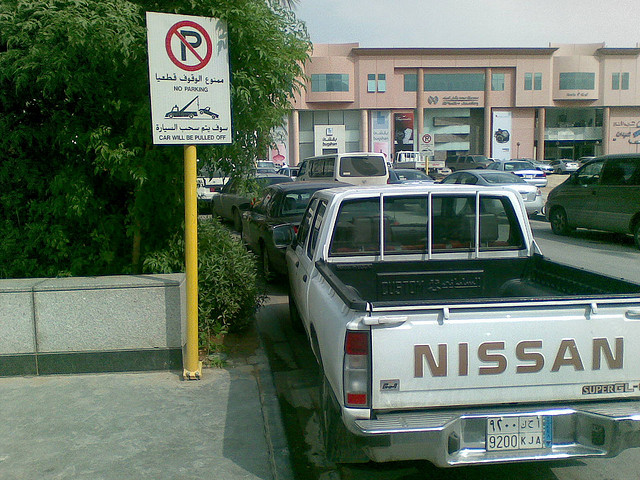Can you describe the environment around the parking space? The parking space is within an urban area, with a paved lot and various other cars in the background. There's a building with shopfronts visible in the distance, and a sidewalk adjacent to the vehicle. 